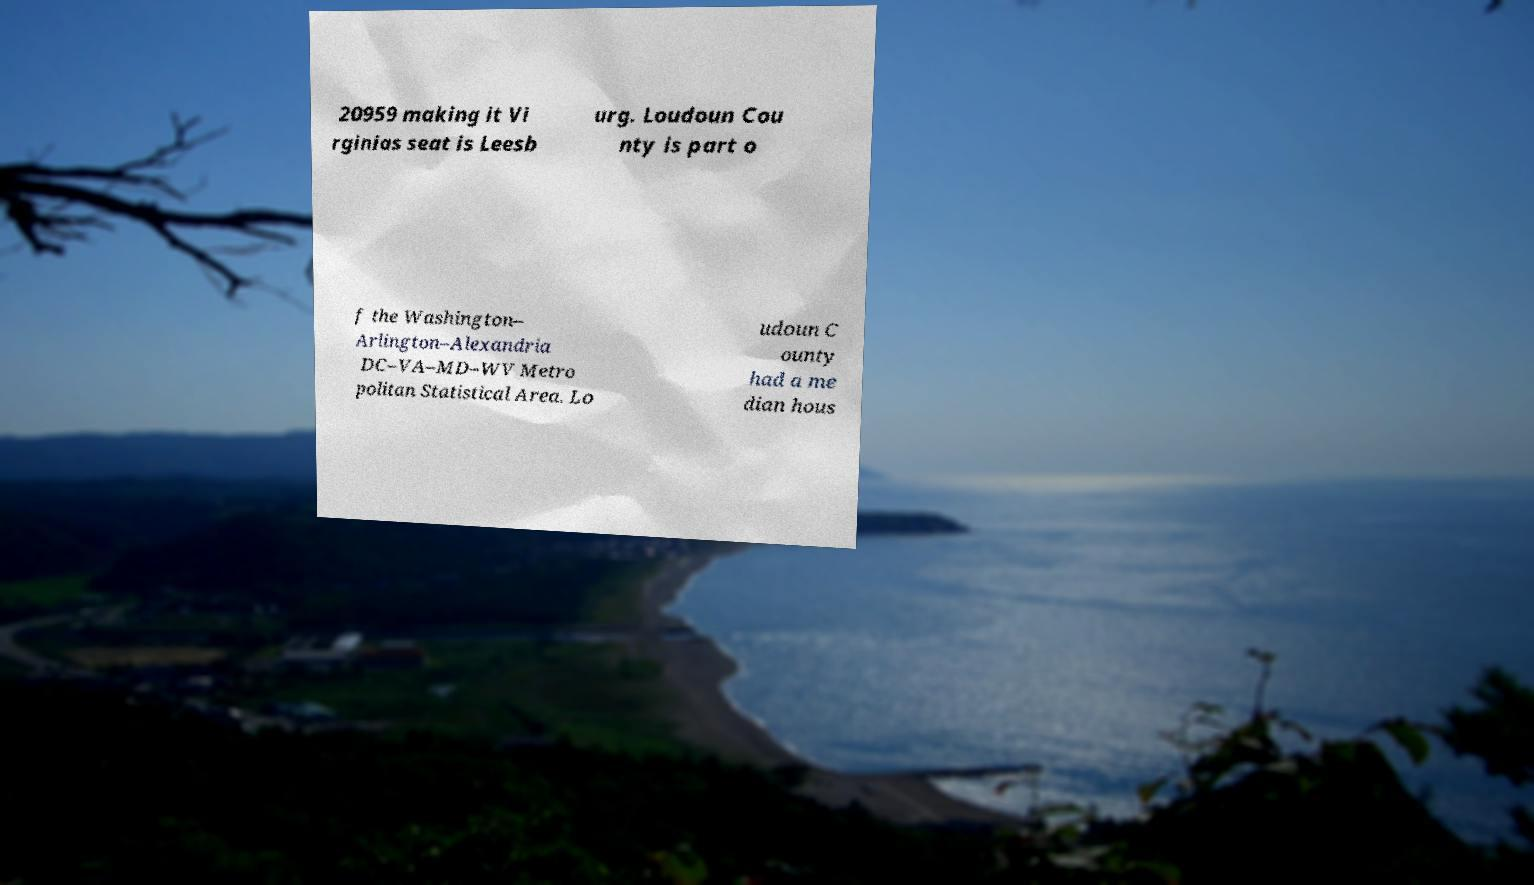There's text embedded in this image that I need extracted. Can you transcribe it verbatim? 20959 making it Vi rginias seat is Leesb urg. Loudoun Cou nty is part o f the Washington– Arlington–Alexandria DC–VA–MD–WV Metro politan Statistical Area. Lo udoun C ounty had a me dian hous 